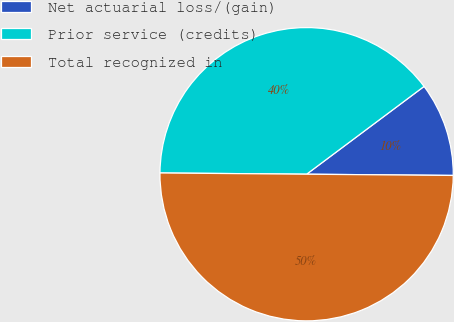<chart> <loc_0><loc_0><loc_500><loc_500><pie_chart><fcel>Net actuarial loss/(gain)<fcel>Prior service (credits)<fcel>Total recognized in<nl><fcel>10.35%<fcel>39.65%<fcel>50.0%<nl></chart> 